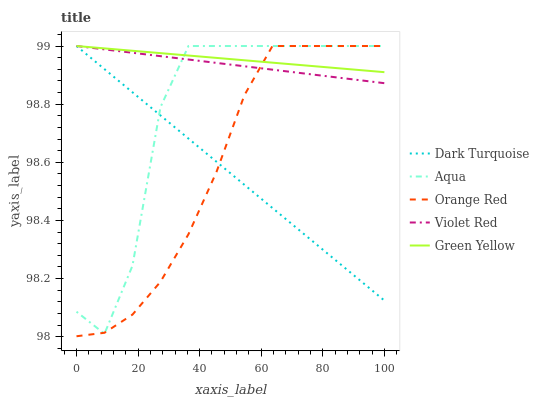Does Dark Turquoise have the minimum area under the curve?
Answer yes or no. Yes. Does Green Yellow have the maximum area under the curve?
Answer yes or no. Yes. Does Violet Red have the minimum area under the curve?
Answer yes or no. No. Does Violet Red have the maximum area under the curve?
Answer yes or no. No. Is Green Yellow the smoothest?
Answer yes or no. Yes. Is Aqua the roughest?
Answer yes or no. Yes. Is Violet Red the smoothest?
Answer yes or no. No. Is Violet Red the roughest?
Answer yes or no. No. Does Orange Red have the lowest value?
Answer yes or no. Yes. Does Violet Red have the lowest value?
Answer yes or no. No. Does Orange Red have the highest value?
Answer yes or no. Yes. Does Aqua intersect Violet Red?
Answer yes or no. Yes. Is Aqua less than Violet Red?
Answer yes or no. No. Is Aqua greater than Violet Red?
Answer yes or no. No. 